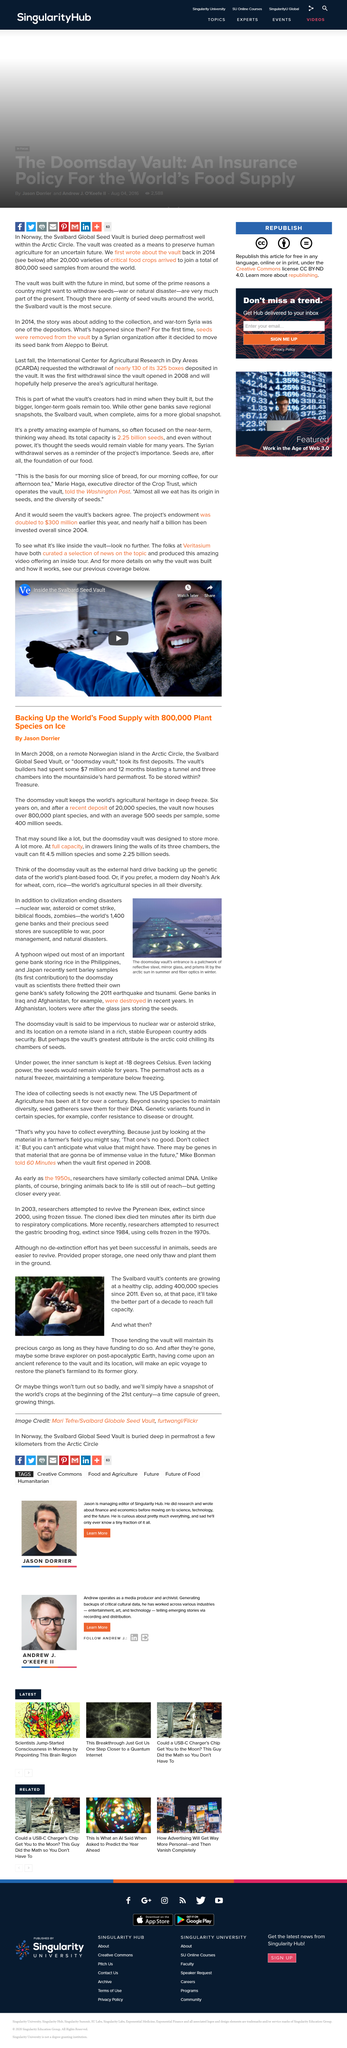Highlight a few significant elements in this photo. Gene banks serve as a vital safeguard against catastrophic events that could decimate humanity, including natural disasters, war, inadequate management, and extreme weather events. The entrance of the doomsday vault is made from reflective steel, mirror glass, and prisms, which serve to protect the stored seeds from environmental threats. The Svalbard Global Seed Vault is located in Norway. Since 2011, approximately 400,000 species have been stored at the Svalbard Global Seed Vault. The Savlbard Vault is a secure and private facility designed specifically for the storage of seeds. 